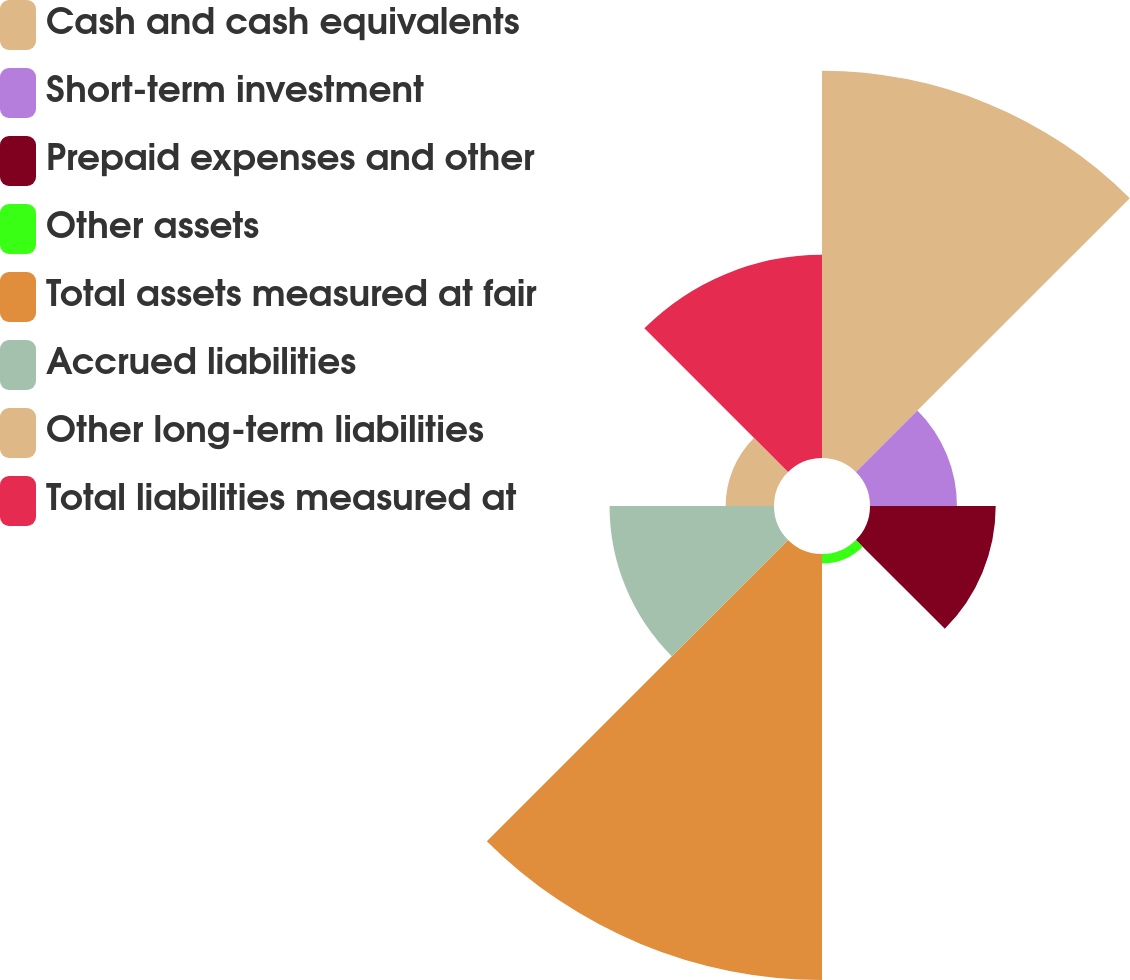Convert chart to OTSL. <chart><loc_0><loc_0><loc_500><loc_500><pie_chart><fcel>Cash and cash equivalents<fcel>Short-term investment<fcel>Prepaid expenses and other<fcel>Other assets<fcel>Total assets measured at fair<fcel>Accrued liabilities<fcel>Other long-term liabilities<fcel>Total liabilities measured at<nl><fcel>26.68%<fcel>5.99%<fcel>8.66%<fcel>0.66%<fcel>29.35%<fcel>11.33%<fcel>3.33%<fcel>14.0%<nl></chart> 